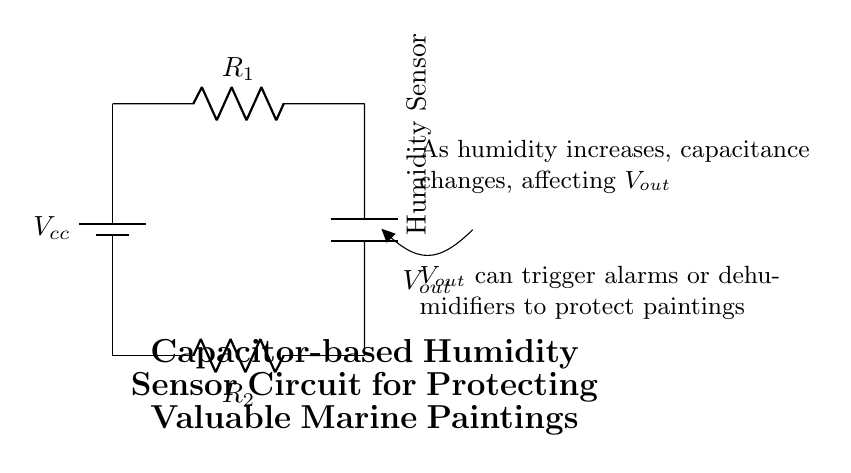What is the type of sensor used in this circuit? The sensor used is a humidity sensor, indicated by the label in the circuit diagram. This component changes its capacitance based on the humidity level, making it suitable for measuring moisture levels.
Answer: Humidity Sensor What is the role of R1 in the circuit? Resistor R1, in series with the power supply, controls the current flowing to the rest of the circuit. It limits the amount of current that reaches the humidity sensor and affects how the sensor operates, impacting the output voltage based on humidity changes.
Answer: Current control What happens to Vout as humidity increases? As humidity increases, the capacitance of the humidity sensor changes, which alters the output voltage Vout. This change is described in the explanatory text of the diagram, indicating a direct relationship between humidity levels and Vout.
Answer: Increases or changes How many resistors are present in this circuit? There are two resistors shown in the circuit: R1 and R2. This can be determined by counting the resistors labeled in the diagram. Each resistor has a different function within the circuit context.
Answer: Two What would likely trigger an alarm in this circuit? An alarm would likely be triggered by Vout reaching a specific threshold, which indicates a certain level of humidity has been detected. This is designed to protect the valuable marine paintings from potential moisture damage.
Answer: Vout threshold Why is a capacitor used in this humidity sensor circuit? A capacitor is used in this circuit because variations in humidity lead to changes in capacitance. This change can be measured as a voltage output, making it an effective way to monitor humidity levels. The relationship between capacitance and humidity allows this circuit to function as a sensor.
Answer: To measure humidity What is the function of R2 in the circuit? Resistor R2 serves to complete the circuit by providing a return path for the current flowing from the humidity sensor to the voltage source. It plays a critical role in determining the voltage and the response of the circuit to changes in humidity.
Answer: Circuit completion 